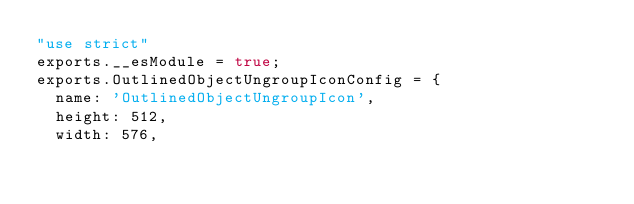<code> <loc_0><loc_0><loc_500><loc_500><_JavaScript_>"use strict"
exports.__esModule = true;
exports.OutlinedObjectUngroupIconConfig = {
  name: 'OutlinedObjectUngroupIcon',
  height: 512,
  width: 576,</code> 